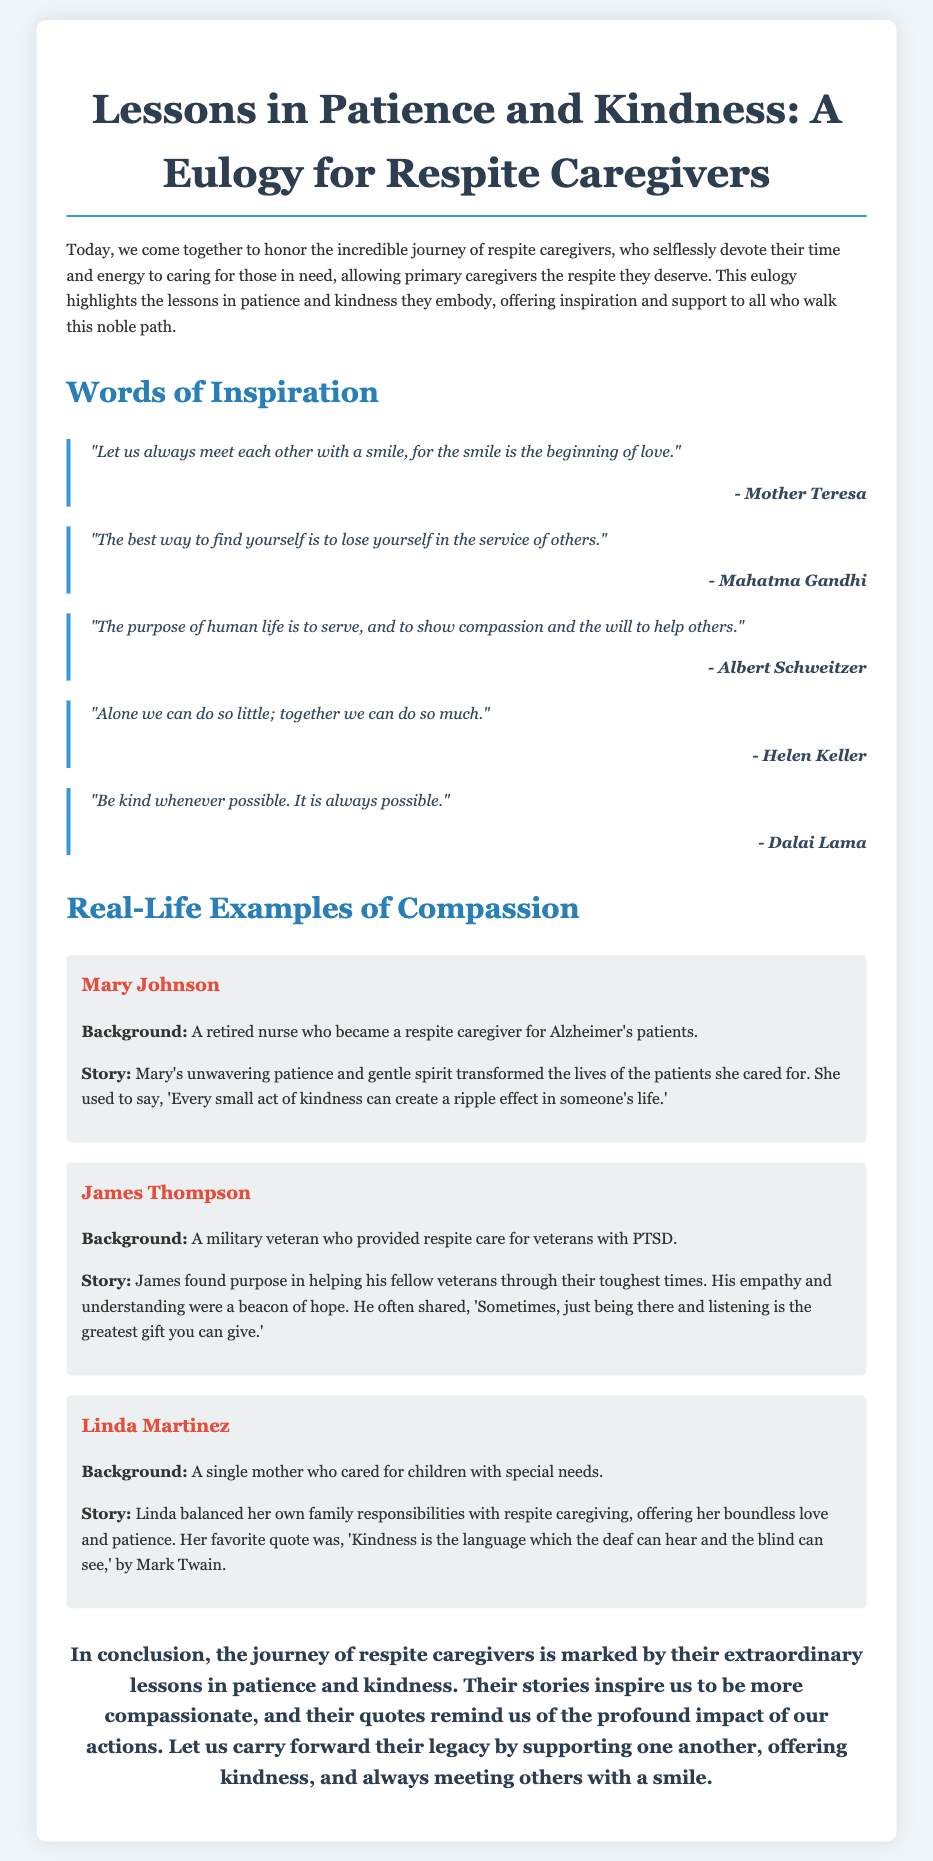What is the title of the eulogy? The title is the header of the document that reflects the main theme and purpose of the eulogy for respite caregivers.
Answer: Lessons in Patience and Kindness: A Eulogy for Respite Caregivers Who is quoted as saying, "Let us always meet each other with a smile"? This question seeks the name of the person who provided this inspirational quote, which is listed in the section of quotes.
Answer: Mother Teresa How many real-life examples are provided in the document? The question asks for a count of the number of real-life examples shared about respite caregivers in the document.
Answer: 3 What is the main theme of the eulogy? This question prompts an understanding of the overarching message and focus of the eulogy as discussed in the introduction.
Answer: Patience and kindness Which quote emphasizes that kindness can be communicated to everyone? The question identifies a specific quote from the document that conveys a universal message about kindness.
Answer: "Kindness is the language which the deaf can hear and the blind can see." What profession did Mary Johnson retire from? This question requests specific background information about one of the real-life examples provided in the document.
Answer: Nurse What lesson do the stories of the caregivers inspire us to embrace? This question aims to deduce the moral or lesson from the real-life examples and quotes shared in the document.
Answer: Compassion Who provided respite care for veterans with PTSD? This question is looking for the name of the person mentioned in the examples who dedicated their time to this specific group.
Answer: James Thompson 